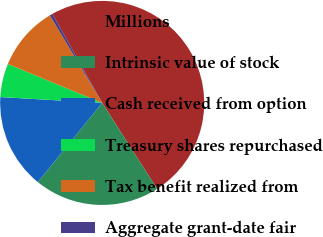Convert chart to OTSL. <chart><loc_0><loc_0><loc_500><loc_500><pie_chart><fcel>Millions<fcel>Intrinsic value of stock<fcel>Cash received from option<fcel>Treasury shares repurchased<fcel>Tax benefit realized from<fcel>Aggregate grant-date fair<nl><fcel>49.07%<fcel>19.91%<fcel>15.05%<fcel>5.32%<fcel>10.19%<fcel>0.46%<nl></chart> 